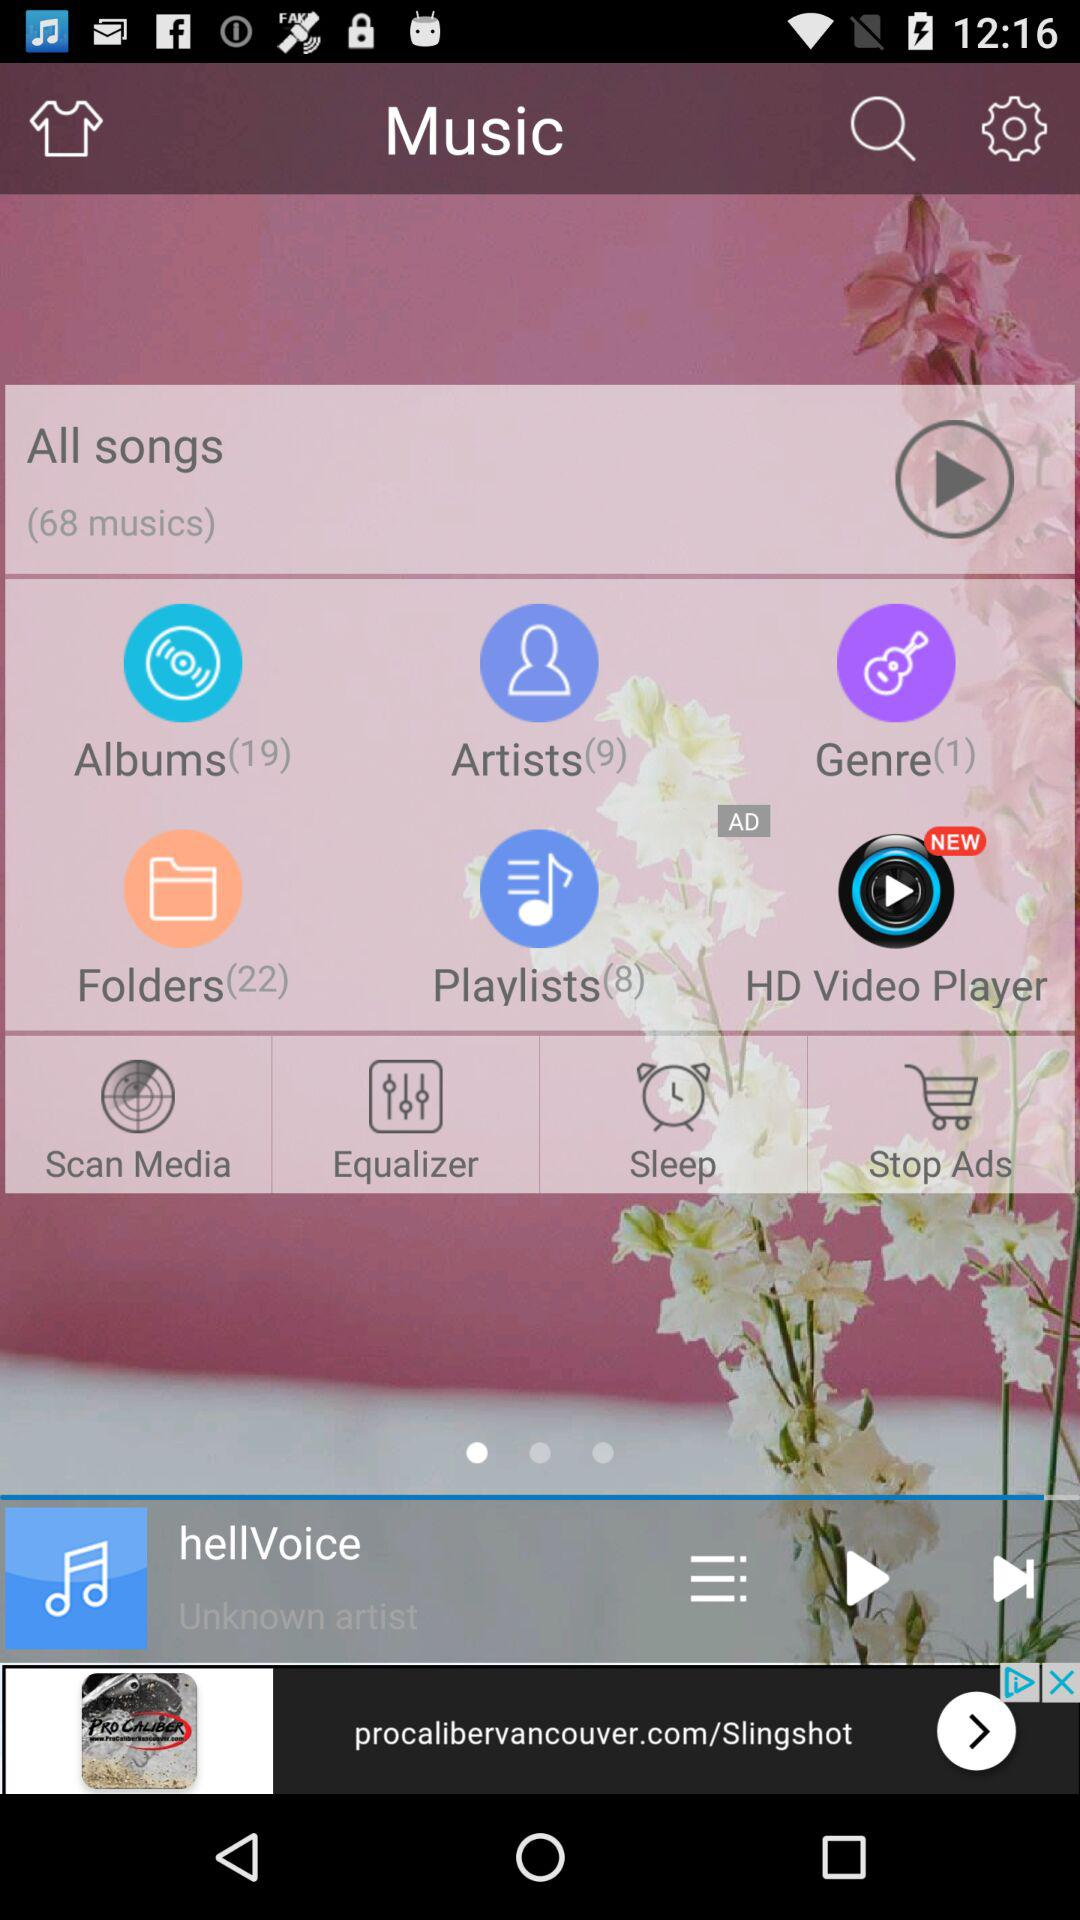How many musics are there in "All songs"? There are 68 musics in "All songs". 